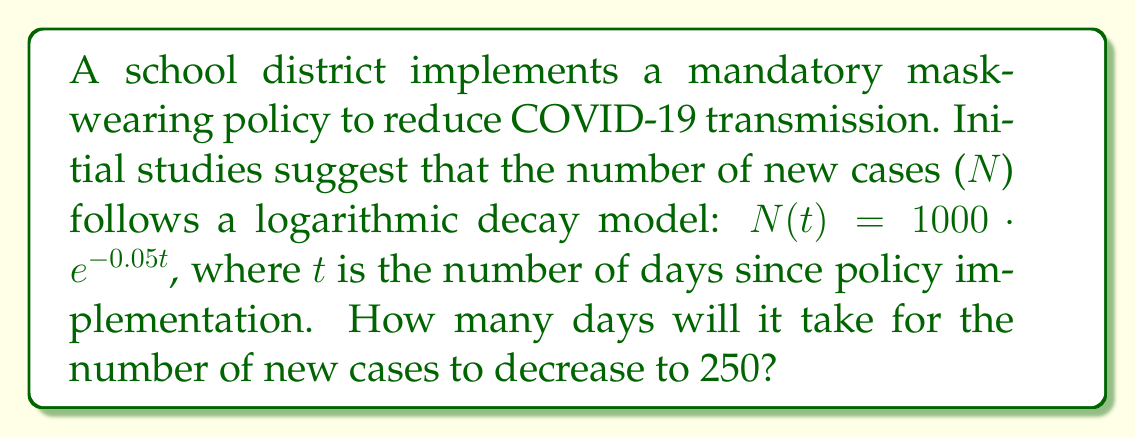Can you solve this math problem? To solve this problem, we'll use the given logarithmic decay model and solve for t:

1) The model is given by: $N(t) = 1000 \cdot e^{-0.05t}$

2) We want to find t when N(t) = 250:
   $250 = 1000 \cdot e^{-0.05t}$

3) Divide both sides by 1000:
   $\frac{250}{1000} = e^{-0.05t}$
   $0.25 = e^{-0.05t}$

4) Take the natural logarithm of both sides:
   $\ln(0.25) = \ln(e^{-0.05t})$
   $\ln(0.25) = -0.05t$

5) Solve for t:
   $t = \frac{\ln(0.25)}{-0.05}$

6) Calculate the result:
   $t = \frac{-1.386}{-0.05} \approx 27.73$

7) Since we're dealing with days, we round up to the nearest whole number:
   $t = 28$ days

Therefore, it will take 28 days for the number of new cases to decrease to 250.
Answer: 28 days 